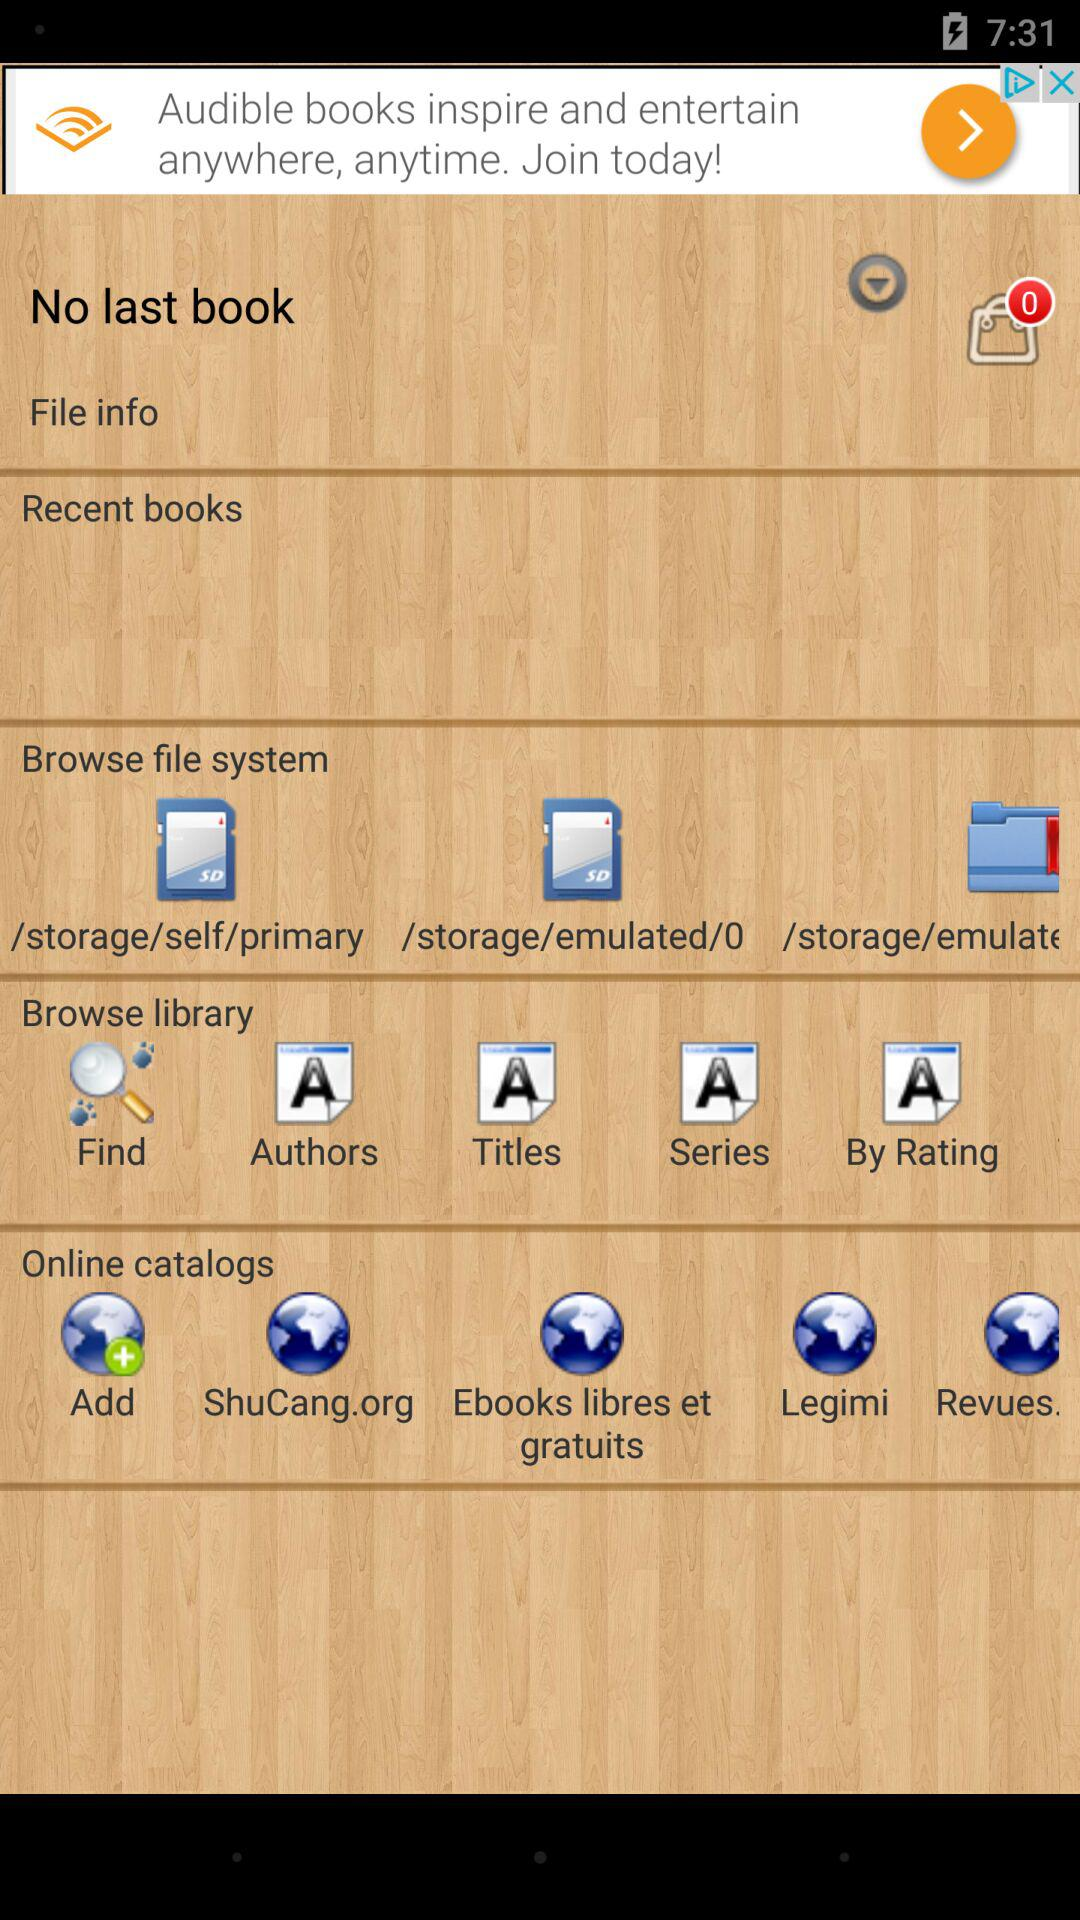How many items are in the bag? There are 0 items in the bag. 